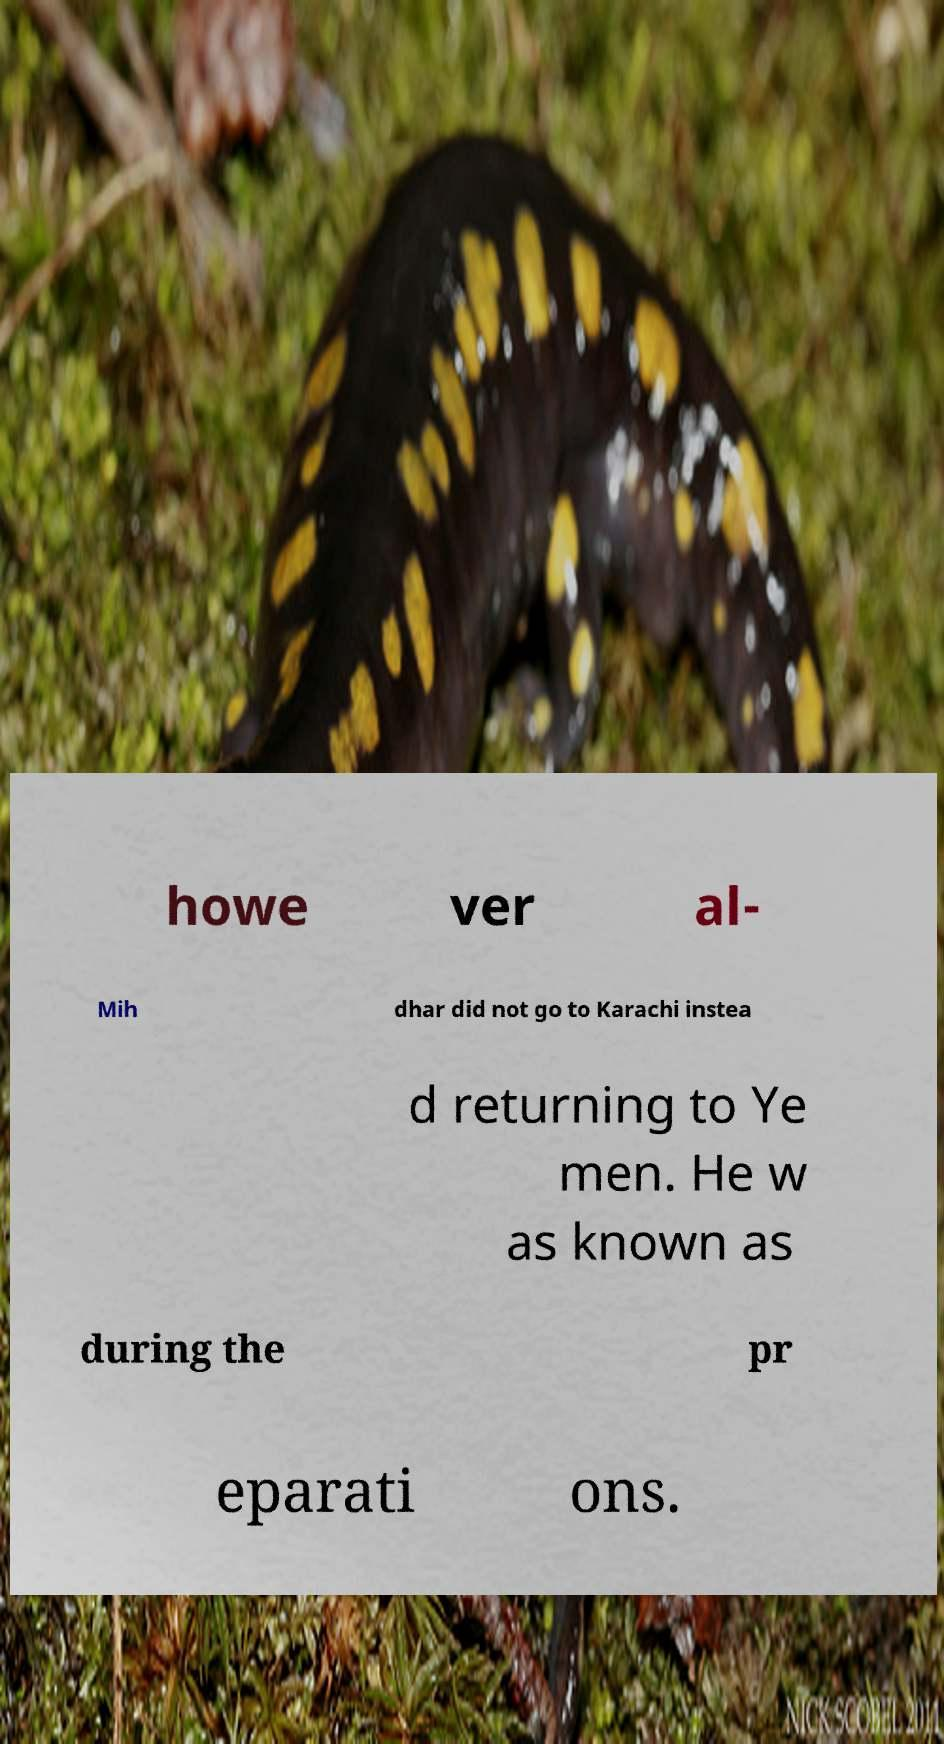I need the written content from this picture converted into text. Can you do that? howe ver al- Mih dhar did not go to Karachi instea d returning to Ye men. He w as known as during the pr eparati ons. 